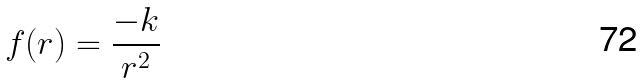<formula> <loc_0><loc_0><loc_500><loc_500>f ( r ) = \frac { - k } { r ^ { 2 } }</formula> 